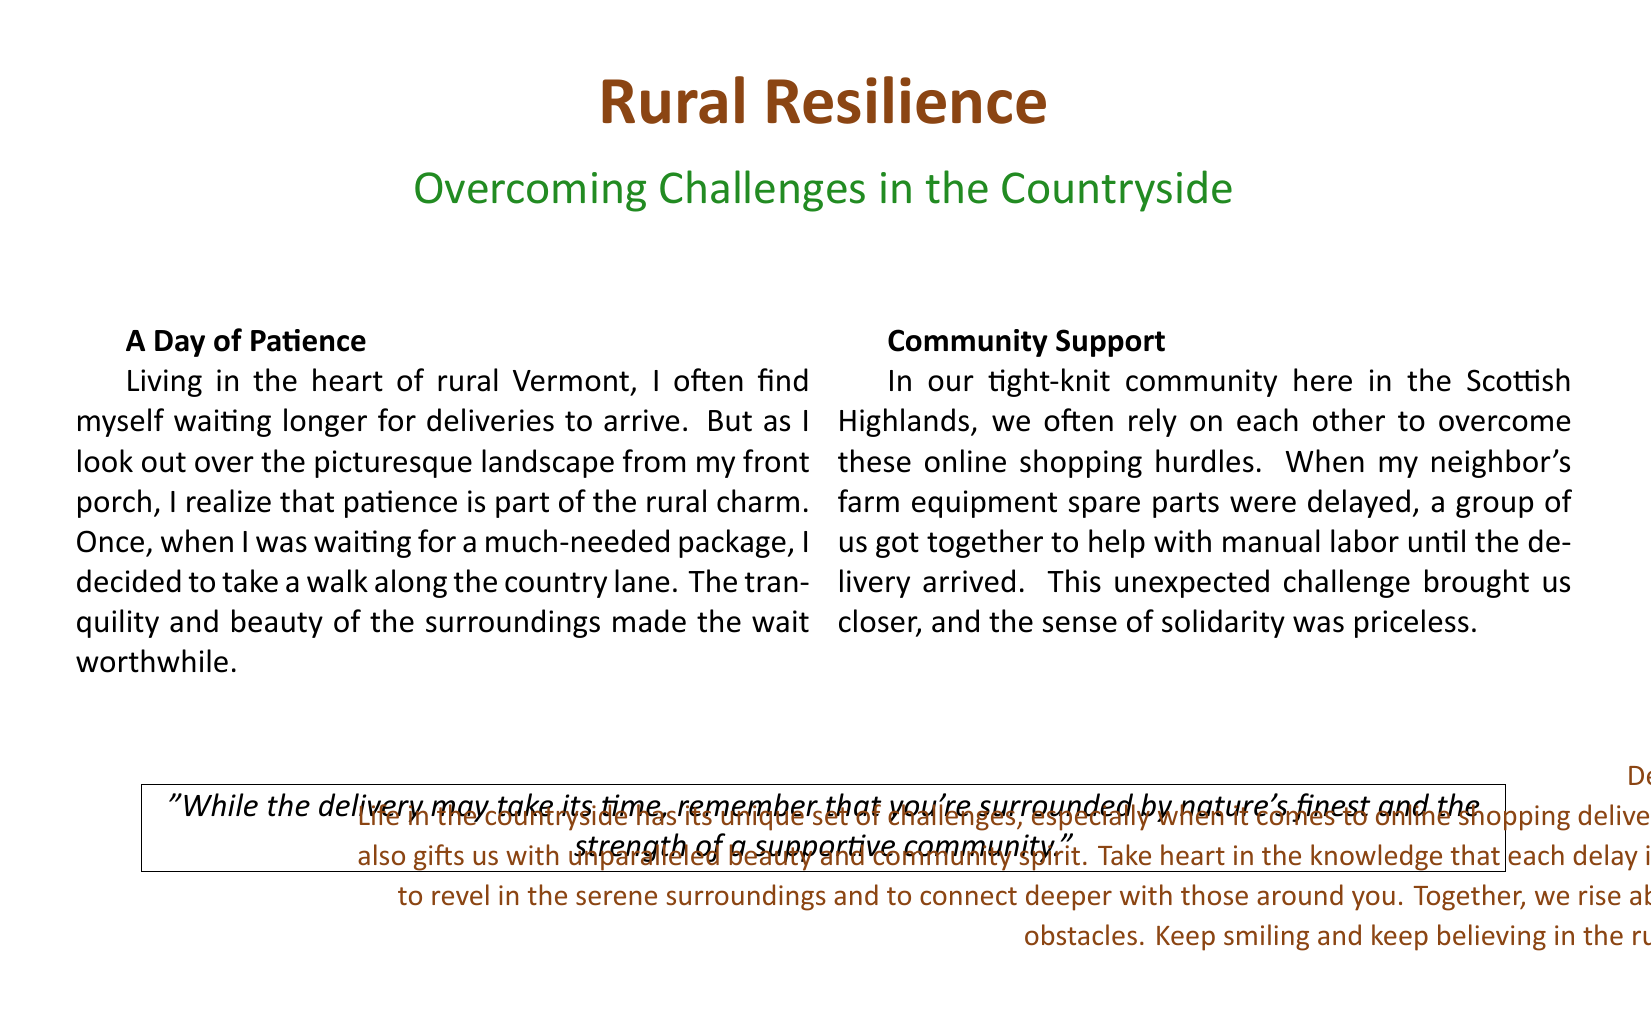What is the title of the card? The title is prominently displayed at the top of the card, emphasizing its central theme.
Answer: Rural Resilience What color is used for the title text? The document specifies the color associated with the title, highlighting its rustic theme.
Answer: Rustic brown Where does the author live? The author provides a specific location that reflects their experience with rural life.
Answer: Rural Vermont What is one challenge mentioned regarding online shopping? The document describes a particular issue faced by rural residents related to e-commerce.
Answer: Delivery delays What supportive action did the community take? The author recounts a cooperative effort by neighbors to solve a logistical problem.
Answer: Manual labor What sentiment is expressed in the quote? The quote encapsulates an encouraging feeling about the rural experience despite challenges.
Answer: Patience and community strength What is the overall theme of the card? The theme captures a central message about dealing with difficulties through positivity and support.
Answer: Overcoming challenges What phrase is used to greet the reader? The closure to the greeting card includes a friendly address to the reader.
Answer: Dear Friend What is a personal anecdote shared in the card? The author includes a specific event from their life to illustrate a point about patience.
Answer: Waiting for a package 